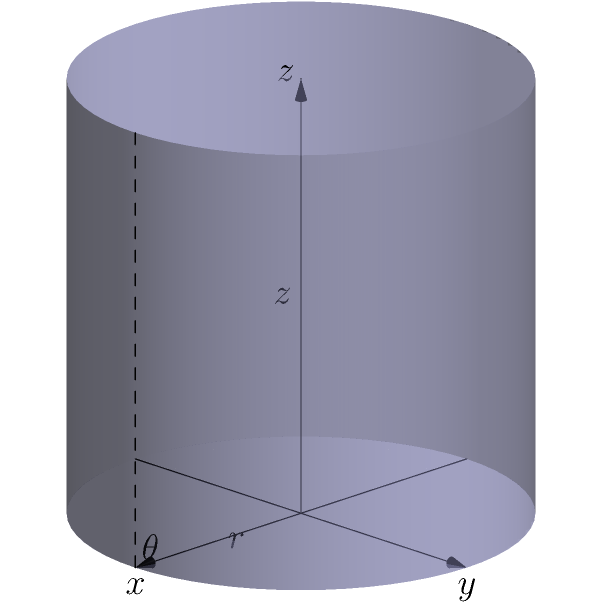In a cloud environment, resource allocation can be modeled using a cylindrical coordinate system $(r, \theta, z)$, where $r$ represents the computational power, $\theta$ represents the type of service, and $z$ represents the network bandwidth. Given that the total available resources are constrained within a cylinder of radius $R=2$ and height $H=3$, how would you express the volume of resources allocated to a specific service type $\theta_0$ with a bandwidth range from $z_1$ to $z_2$? To solve this problem, we need to follow these steps:

1) In a cylindrical coordinate system, the volume element is given by $dV = r \, dr \, d\theta \, dz$.

2) We need to integrate this volume element over the specified region:
   - $r$ goes from 0 to $R$ (full radius)
   - $\theta$ is fixed at $\theta_0$ (specific service type)
   - $z$ goes from $z_1$ to $z_2$ (specified bandwidth range)

3) The volume integral in cylindrical coordinates is:

   $$V = \int_{z_1}^{z_2} \int_{0}^{2\pi} \int_{0}^{R} r \, dr \, d\theta \, dz$$

4) Since we're looking at a specific service type $\theta_0$, we're essentially taking a "slice" of the cylinder. This means we don't integrate over $\theta$, but instead use a small angular width $d\theta$.

5) Our volume integral becomes:

   $$V = d\theta \int_{z_1}^{z_2} \int_{0}^{R} r \, dr \, dz$$

6) Solving the inner integral:

   $$V = d\theta \int_{z_1}^{z_2} [\frac{1}{2}r^2]_{0}^{R} \, dz = d\theta \int_{z_1}^{z_2} \frac{1}{2}R^2 \, dz$$

7) Solving the outer integral:

   $$V = d\theta \cdot \frac{1}{2}R^2 [z]_{z_1}^{z_2} = d\theta \cdot \frac{1}{2}R^2 (z_2 - z_1)$$

8) Substituting the given value $R=2$:

   $$V = d\theta \cdot 2(z_2 - z_1)$$

This expression represents the volume of resources allocated to a specific service type $\theta_0$ with a bandwidth range from $z_1$ to $z_2$.
Answer: $V = d\theta \cdot 2(z_2 - z_1)$ 